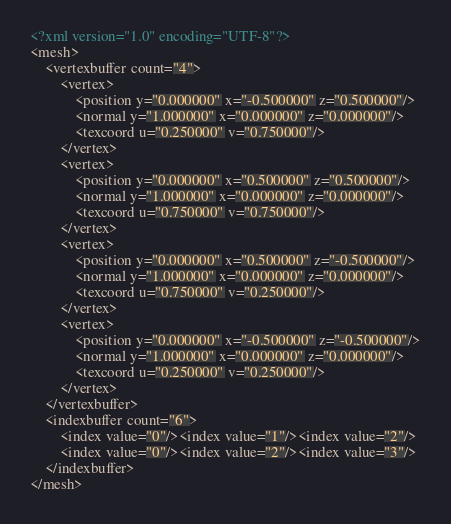<code> <loc_0><loc_0><loc_500><loc_500><_XML_><?xml version="1.0" encoding="UTF-8"?>
<mesh>
	<vertexbuffer count="4">
		<vertex>
			<position y="0.000000" x="-0.500000" z="0.500000"/>
			<normal y="1.000000" x="0.000000" z="0.000000"/>
			<texcoord u="0.250000" v="0.750000"/>
		</vertex>
		<vertex>
			<position y="0.000000" x="0.500000" z="0.500000"/>
			<normal y="1.000000" x="0.000000" z="0.000000"/>
			<texcoord u="0.750000" v="0.750000"/>
		</vertex>
		<vertex>
			<position y="0.000000" x="0.500000" z="-0.500000"/>
			<normal y="1.000000" x="0.000000" z="0.000000"/>
			<texcoord u="0.750000" v="0.250000"/>
		</vertex>
		<vertex>
			<position y="0.000000" x="-0.500000" z="-0.500000"/>
			<normal y="1.000000" x="0.000000" z="0.000000"/>
			<texcoord u="0.250000" v="0.250000"/>
		</vertex>
	</vertexbuffer>
	<indexbuffer count="6">
		<index value="0"/><index value="1"/><index value="2"/>
		<index value="0"/><index value="2"/><index value="3"/>
	</indexbuffer>
</mesh></code> 